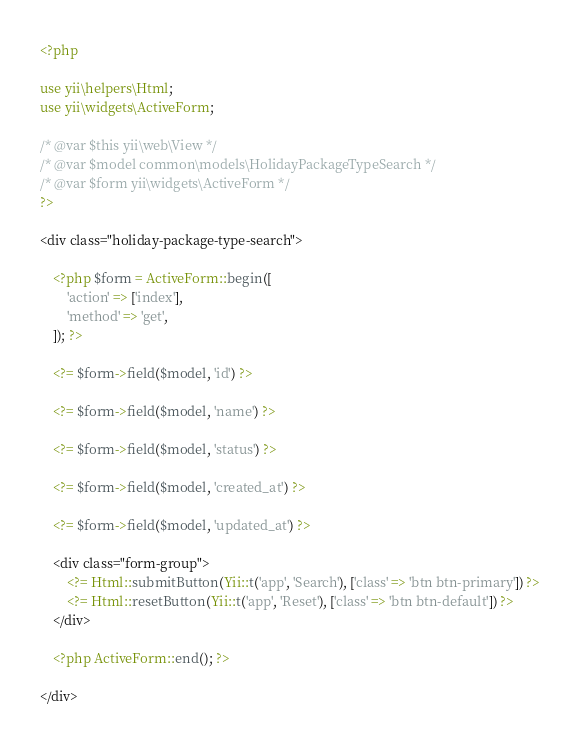Convert code to text. <code><loc_0><loc_0><loc_500><loc_500><_PHP_><?php

use yii\helpers\Html;
use yii\widgets\ActiveForm;

/* @var $this yii\web\View */
/* @var $model common\models\HolidayPackageTypeSearch */
/* @var $form yii\widgets\ActiveForm */
?>

<div class="holiday-package-type-search">

    <?php $form = ActiveForm::begin([
        'action' => ['index'],
        'method' => 'get',
    ]); ?>

    <?= $form->field($model, 'id') ?>

    <?= $form->field($model, 'name') ?>

    <?= $form->field($model, 'status') ?>

    <?= $form->field($model, 'created_at') ?>

    <?= $form->field($model, 'updated_at') ?>

    <div class="form-group">
        <?= Html::submitButton(Yii::t('app', 'Search'), ['class' => 'btn btn-primary']) ?>
        <?= Html::resetButton(Yii::t('app', 'Reset'), ['class' => 'btn btn-default']) ?>
    </div>

    <?php ActiveForm::end(); ?>

</div>
</code> 